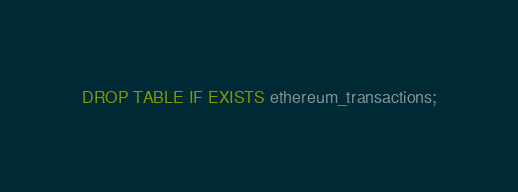Convert code to text. <code><loc_0><loc_0><loc_500><loc_500><_SQL_>DROP TABLE IF EXISTS ethereum_transactions;
</code> 